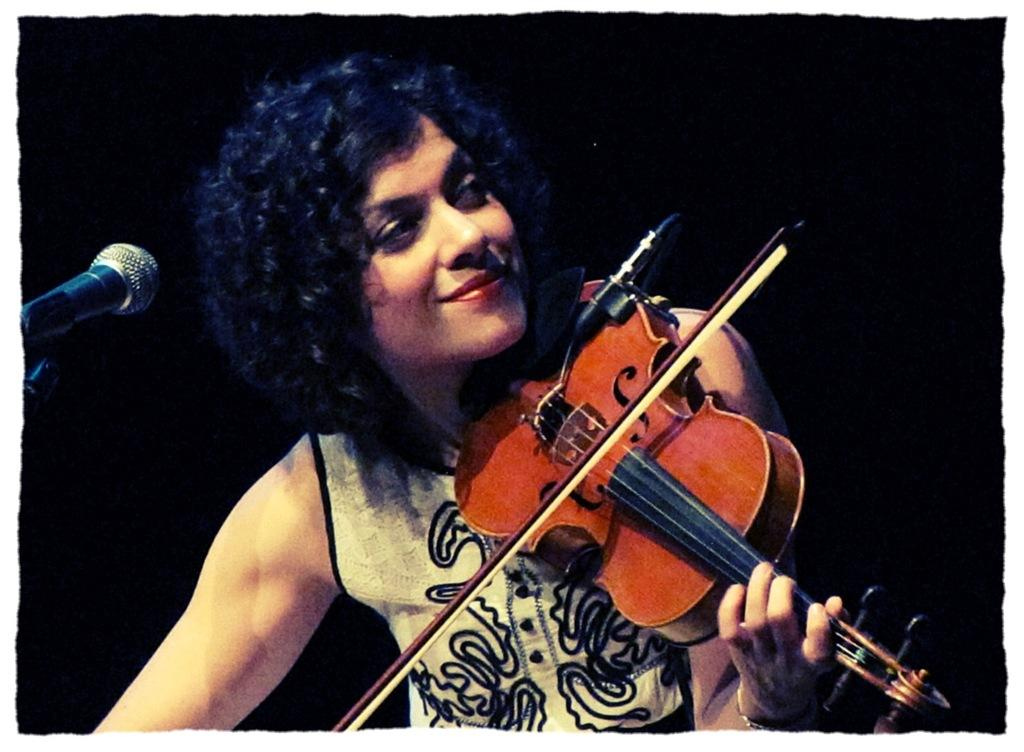Who is the main subject in the image? There is a woman in the image. What is the woman doing in the image? The woman is playing a guitar. What object is present in the image that is commonly used for amplifying sound? There is a microphone in the image. How many cherries are on the woman's head in the image? There are no cherries present on the woman's head in the image. What type of feather can be seen in the woman's hair in the image? There is no feather present in the woman's hair in the image. 